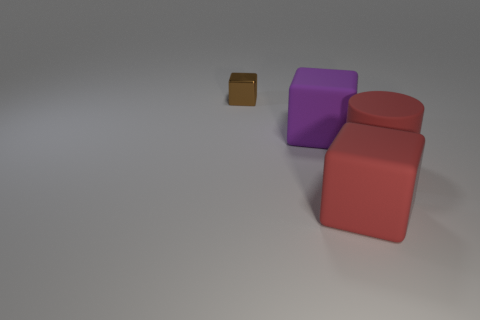There is a tiny metal object that is the same shape as the big purple thing; what color is it?
Provide a short and direct response. Brown. What shape is the red rubber thing that is in front of the large red rubber thing that is behind the red matte object in front of the red rubber cylinder?
Your response must be concise. Cube. Is the number of brown blocks less than the number of red things?
Your answer should be very brief. Yes. How big is the metallic object that is left of the large red cylinder?
Make the answer very short. Small. There is a rubber thing that is on the left side of the large red matte cylinder and on the right side of the large purple matte block; what is its shape?
Give a very brief answer. Cube. What size is the brown object that is the same shape as the purple rubber object?
Keep it short and to the point. Small. What number of other cubes have the same material as the large red block?
Offer a very short reply. 1. There is a big cylinder; does it have the same color as the object that is behind the big purple object?
Your answer should be very brief. No. Is the number of big purple blocks greater than the number of large red objects?
Your answer should be very brief. No. What is the color of the large cylinder?
Offer a terse response. Red. 